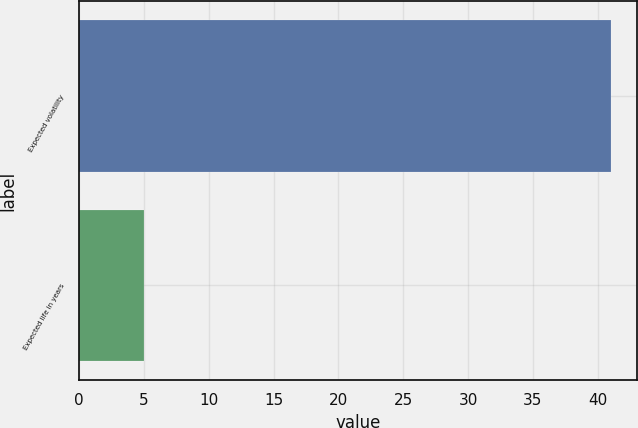Convert chart to OTSL. <chart><loc_0><loc_0><loc_500><loc_500><bar_chart><fcel>Expected volatility<fcel>Expected life in years<nl><fcel>41<fcel>5<nl></chart> 